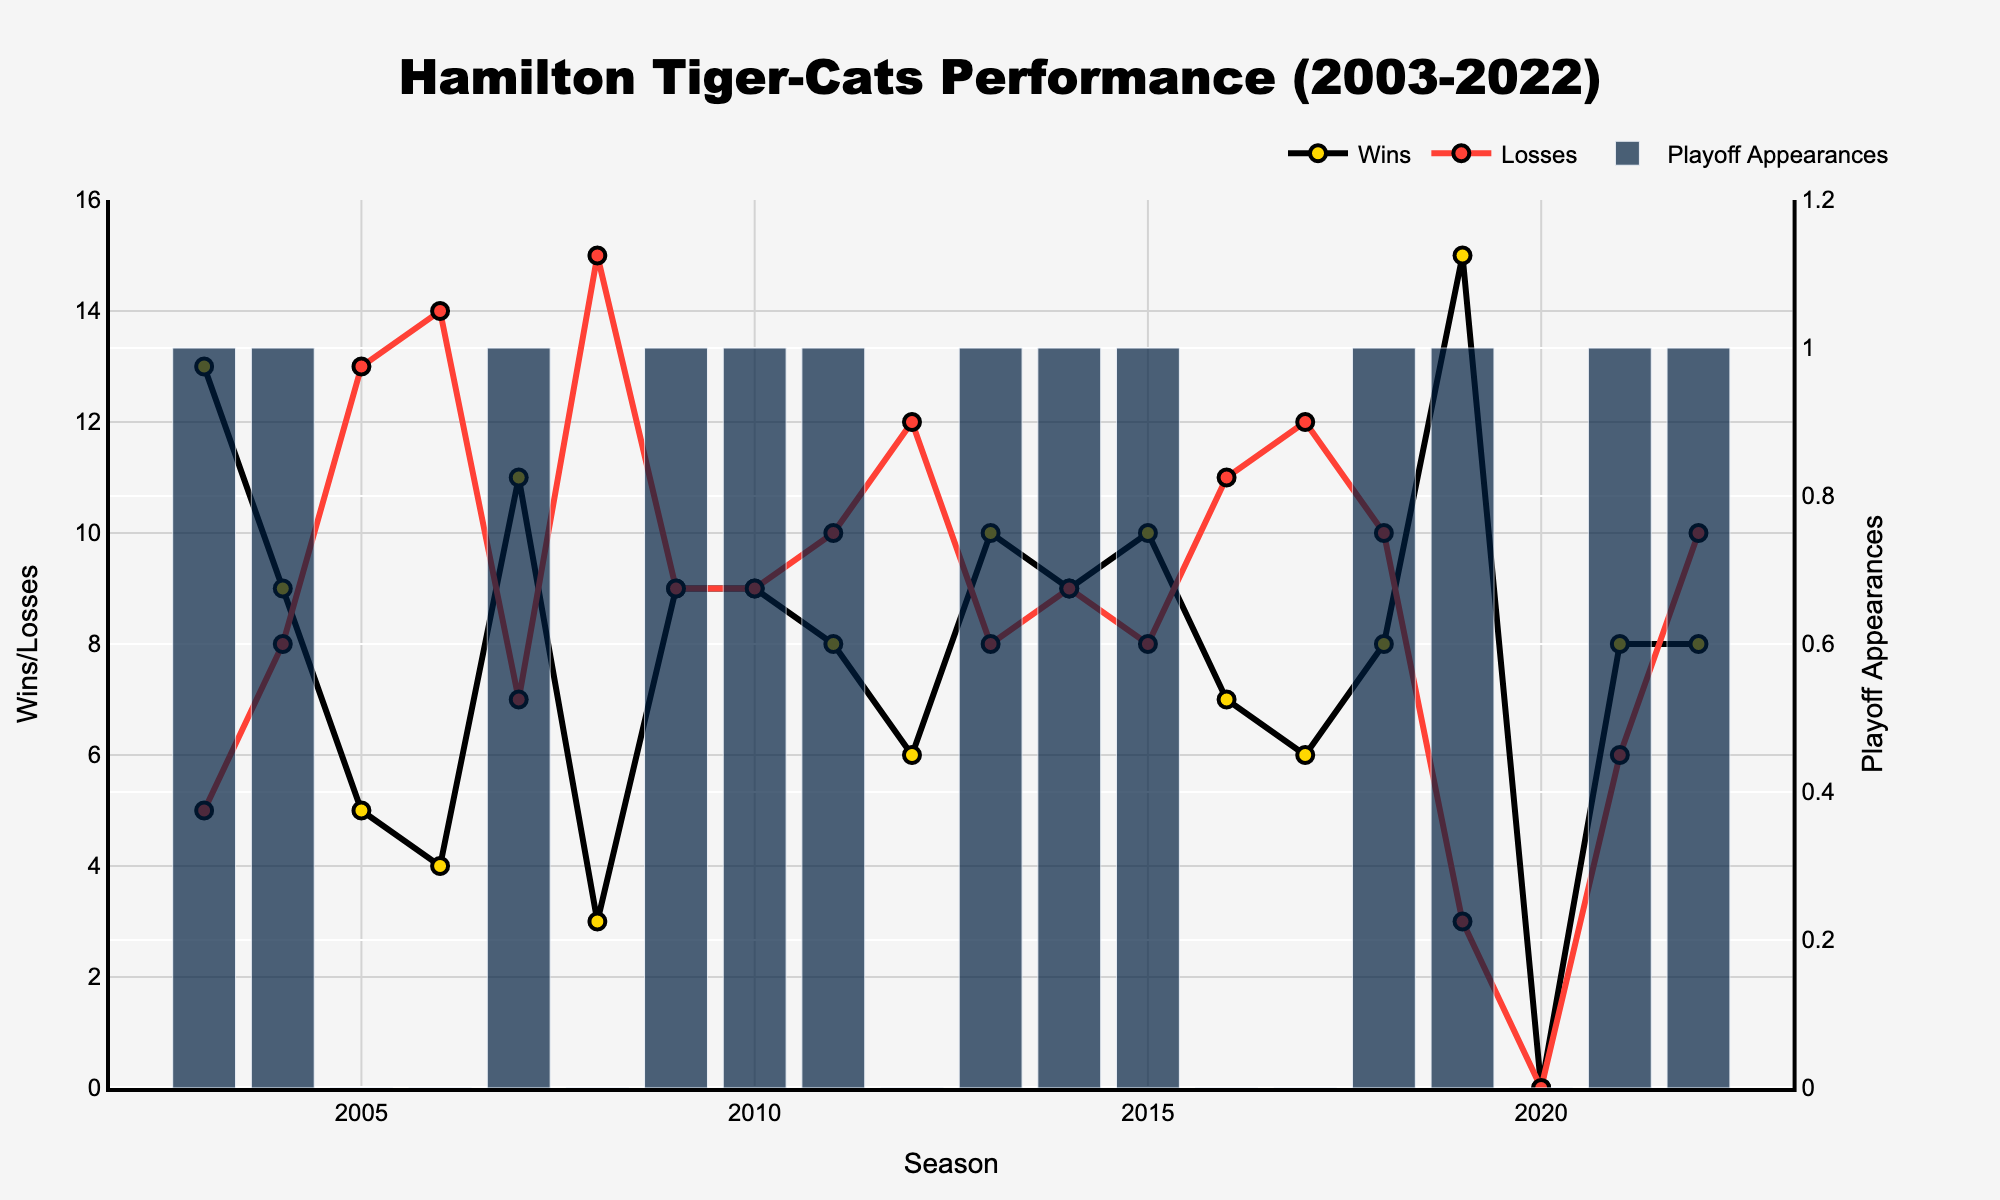How many times did the Hamilton Tiger-Cats make it to the playoffs in the last 20 seasons? Count the number of bars representing playoff appearances in the figure.
Answer: 13 In which season did the Hamilton Tiger-Cats achieve the highest number of regular season wins? Look for the peak point on the line representing wins and identify the corresponding season.
Answer: 2019 Which season had the highest number of regular season losses? Find the highest point on the line representing losses and identify the corresponding season.
Answer: 2006 How many seasons had equal wins and losses (i.e., 9 wins and 9 losses)? Identify the points on the chart where the number of wins equals the number of losses and count them.
Answer: 3 What is the average number of regular season wins from 2003 to 2022? Sum up all the regular season wins and divide by the total number of seasons (20). (13+9+5+4+11+3+9+9+8+6+10+9+10+7+6+8+15+0+8+8 = 158. 158/20 = 7.9)
Answer: 7.9 Compare the number of wins in 2009 and 2010. Were they greater, less, or equal? Look at the points for wins in the 2009 and 2010 seasons and compare them.
Answer: Equal In which season did the Hamilton Tiger-Cats have the largest difference between wins and losses? Calculate the difference between wins and losses for each season and identify the season with the largest difference. (2019: 15-3 = 12)
Answer: 2019 How many times did the Hamilton Tiger-Cats not make the playoffs while having at least 7 wins in a season? Identify and count seasons where wins were at least 7 and playoff appearances were 0. (2005, 2016, 2017)
Answer: 3 Which season had a balance of wins and losses but no playoff appearance? Find seasons with an equal number of wins and losses and check if playoff appearances for those seasons are 0.
Answer: None What is the trend in playoff appearances over the past 3 seasons? Observe the presence of bars for playoff appearances for the last 3 seasons (2020, 2021, 2022). (Playoff appearances: 0 (2020), 1 (2021), 1 (2022))
Answer: Increasing 